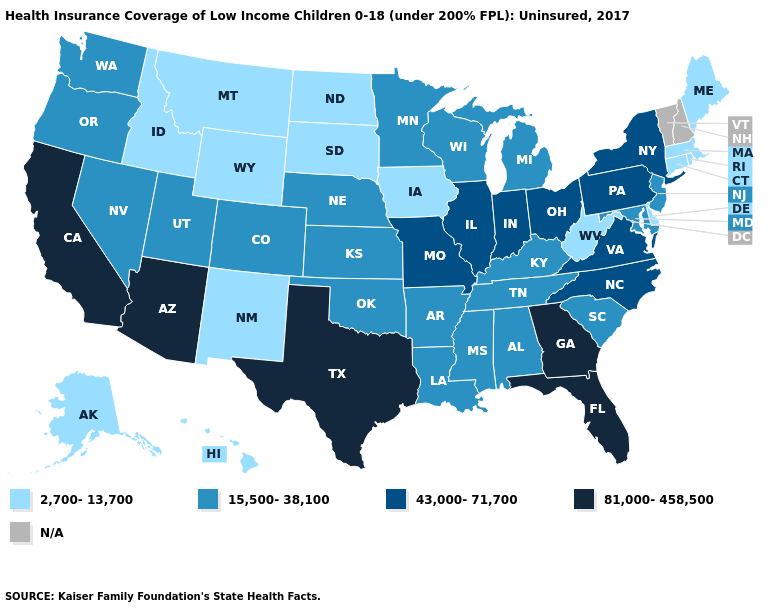Which states hav the highest value in the MidWest?
Answer briefly. Illinois, Indiana, Missouri, Ohio. What is the value of Texas?
Be succinct. 81,000-458,500. Does West Virginia have the highest value in the USA?
Concise answer only. No. What is the value of Oregon?
Short answer required. 15,500-38,100. Among the states that border West Virginia , which have the highest value?
Answer briefly. Ohio, Pennsylvania, Virginia. Among the states that border Ohio , which have the lowest value?
Short answer required. West Virginia. Does Arizona have the highest value in the USA?
Answer briefly. Yes. Name the states that have a value in the range 15,500-38,100?
Quick response, please. Alabama, Arkansas, Colorado, Kansas, Kentucky, Louisiana, Maryland, Michigan, Minnesota, Mississippi, Nebraska, Nevada, New Jersey, Oklahoma, Oregon, South Carolina, Tennessee, Utah, Washington, Wisconsin. Does the first symbol in the legend represent the smallest category?
Short answer required. Yes. What is the lowest value in the USA?
Short answer required. 2,700-13,700. Does West Virginia have the lowest value in the South?
Concise answer only. Yes. What is the highest value in states that border Tennessee?
Give a very brief answer. 81,000-458,500. What is the value of Hawaii?
Answer briefly. 2,700-13,700. 